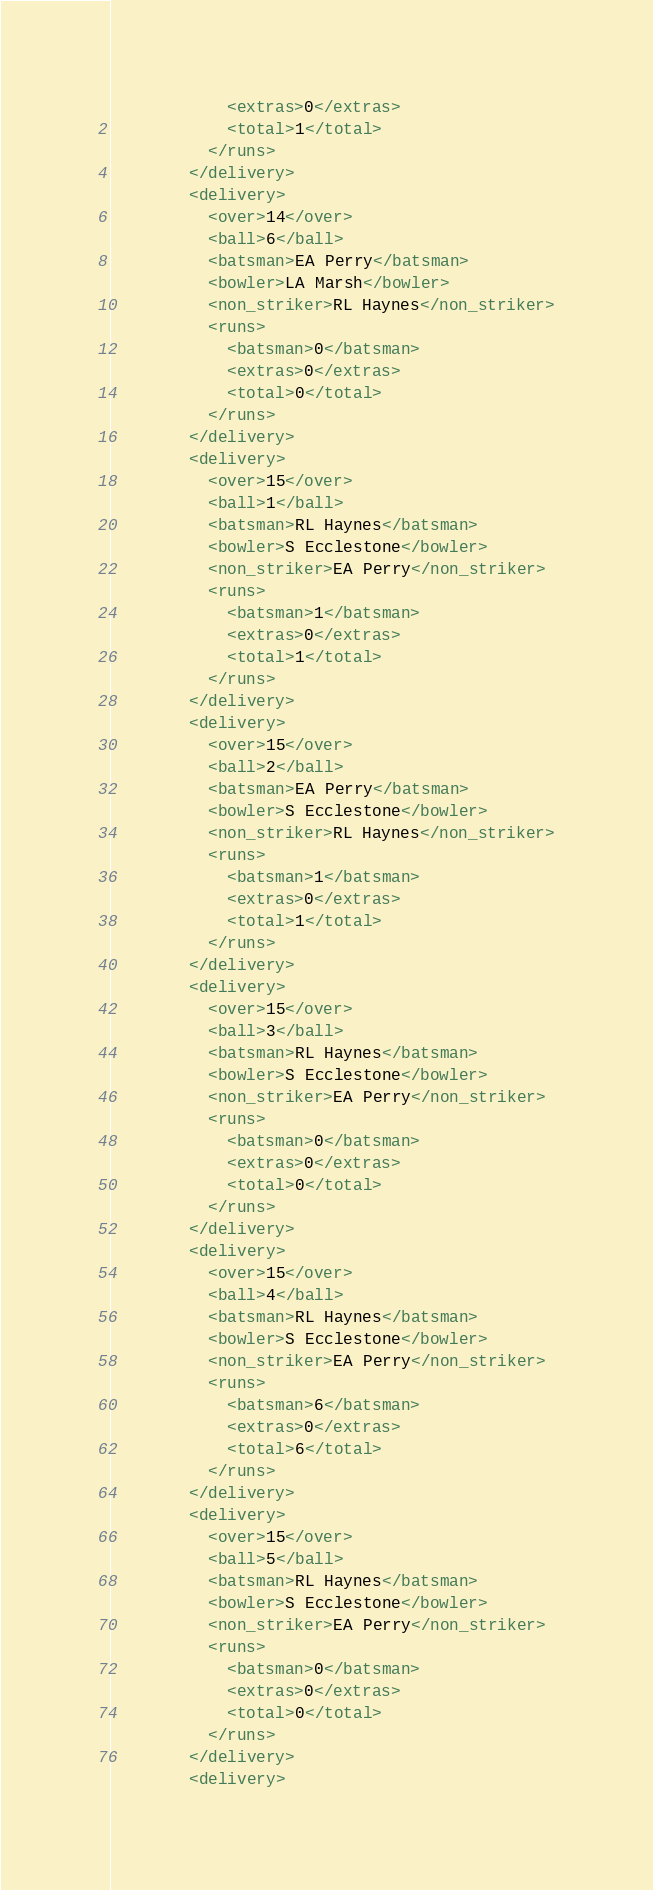<code> <loc_0><loc_0><loc_500><loc_500><_XML_>            <extras>0</extras>
            <total>1</total>
          </runs>
        </delivery>
        <delivery>
          <over>14</over>
          <ball>6</ball>
          <batsman>EA Perry</batsman>
          <bowler>LA Marsh</bowler>
          <non_striker>RL Haynes</non_striker>
          <runs>
            <batsman>0</batsman>
            <extras>0</extras>
            <total>0</total>
          </runs>
        </delivery>
        <delivery>
          <over>15</over>
          <ball>1</ball>
          <batsman>RL Haynes</batsman>
          <bowler>S Ecclestone</bowler>
          <non_striker>EA Perry</non_striker>
          <runs>
            <batsman>1</batsman>
            <extras>0</extras>
            <total>1</total>
          </runs>
        </delivery>
        <delivery>
          <over>15</over>
          <ball>2</ball>
          <batsman>EA Perry</batsman>
          <bowler>S Ecclestone</bowler>
          <non_striker>RL Haynes</non_striker>
          <runs>
            <batsman>1</batsman>
            <extras>0</extras>
            <total>1</total>
          </runs>
        </delivery>
        <delivery>
          <over>15</over>
          <ball>3</ball>
          <batsman>RL Haynes</batsman>
          <bowler>S Ecclestone</bowler>
          <non_striker>EA Perry</non_striker>
          <runs>
            <batsman>0</batsman>
            <extras>0</extras>
            <total>0</total>
          </runs>
        </delivery>
        <delivery>
          <over>15</over>
          <ball>4</ball>
          <batsman>RL Haynes</batsman>
          <bowler>S Ecclestone</bowler>
          <non_striker>EA Perry</non_striker>
          <runs>
            <batsman>6</batsman>
            <extras>0</extras>
            <total>6</total>
          </runs>
        </delivery>
        <delivery>
          <over>15</over>
          <ball>5</ball>
          <batsman>RL Haynes</batsman>
          <bowler>S Ecclestone</bowler>
          <non_striker>EA Perry</non_striker>
          <runs>
            <batsman>0</batsman>
            <extras>0</extras>
            <total>0</total>
          </runs>
        </delivery>
        <delivery></code> 